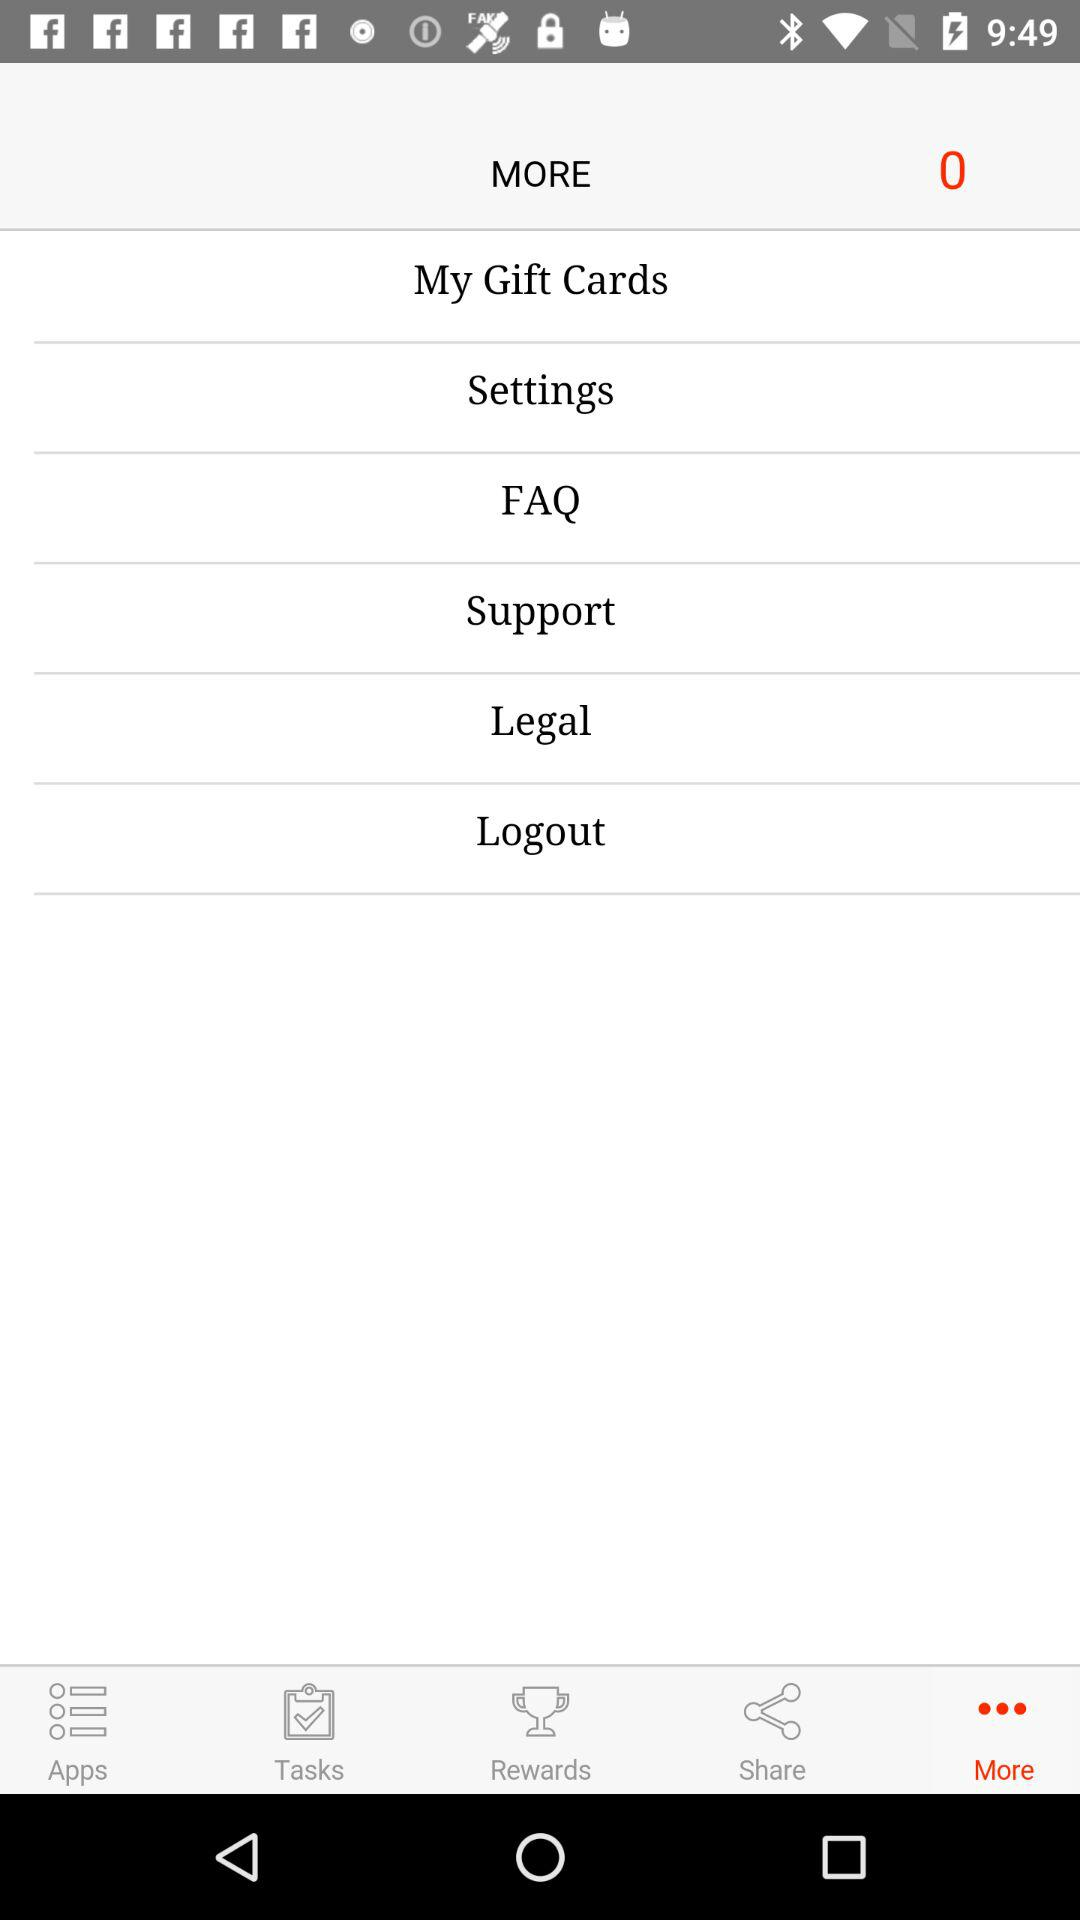Which tab is selected? The selected tab is "More". 